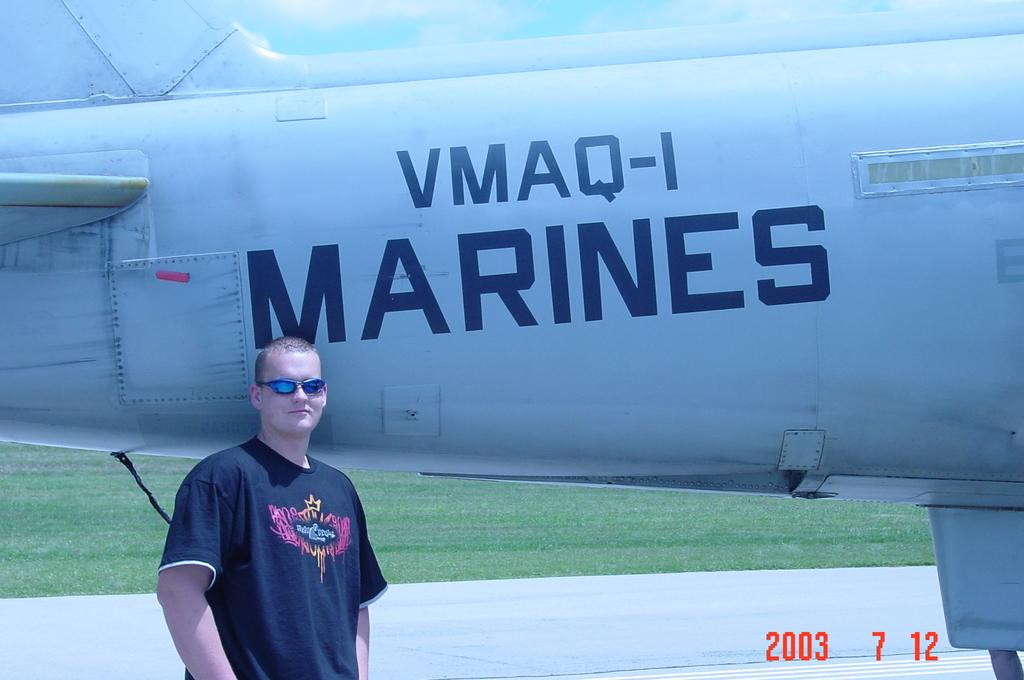What is the main subject of the image? There is a person standing in the image. What type of terrain is visible in the image? There is grass visible in the image. What else can be seen in the image besides the person? A part of a plane is present in the image. Are there any additional details visible at the bottom of the image? Yes, there are numbers visible at the bottom of the image. What type of shoe is the person wearing in the image? There is no visible shoe on the person's feet in the image. What company is responsible for the apparatus seen in the image? There is no apparatus visible in the image; only a person, grass, a part of a plane, and numbers are present. 